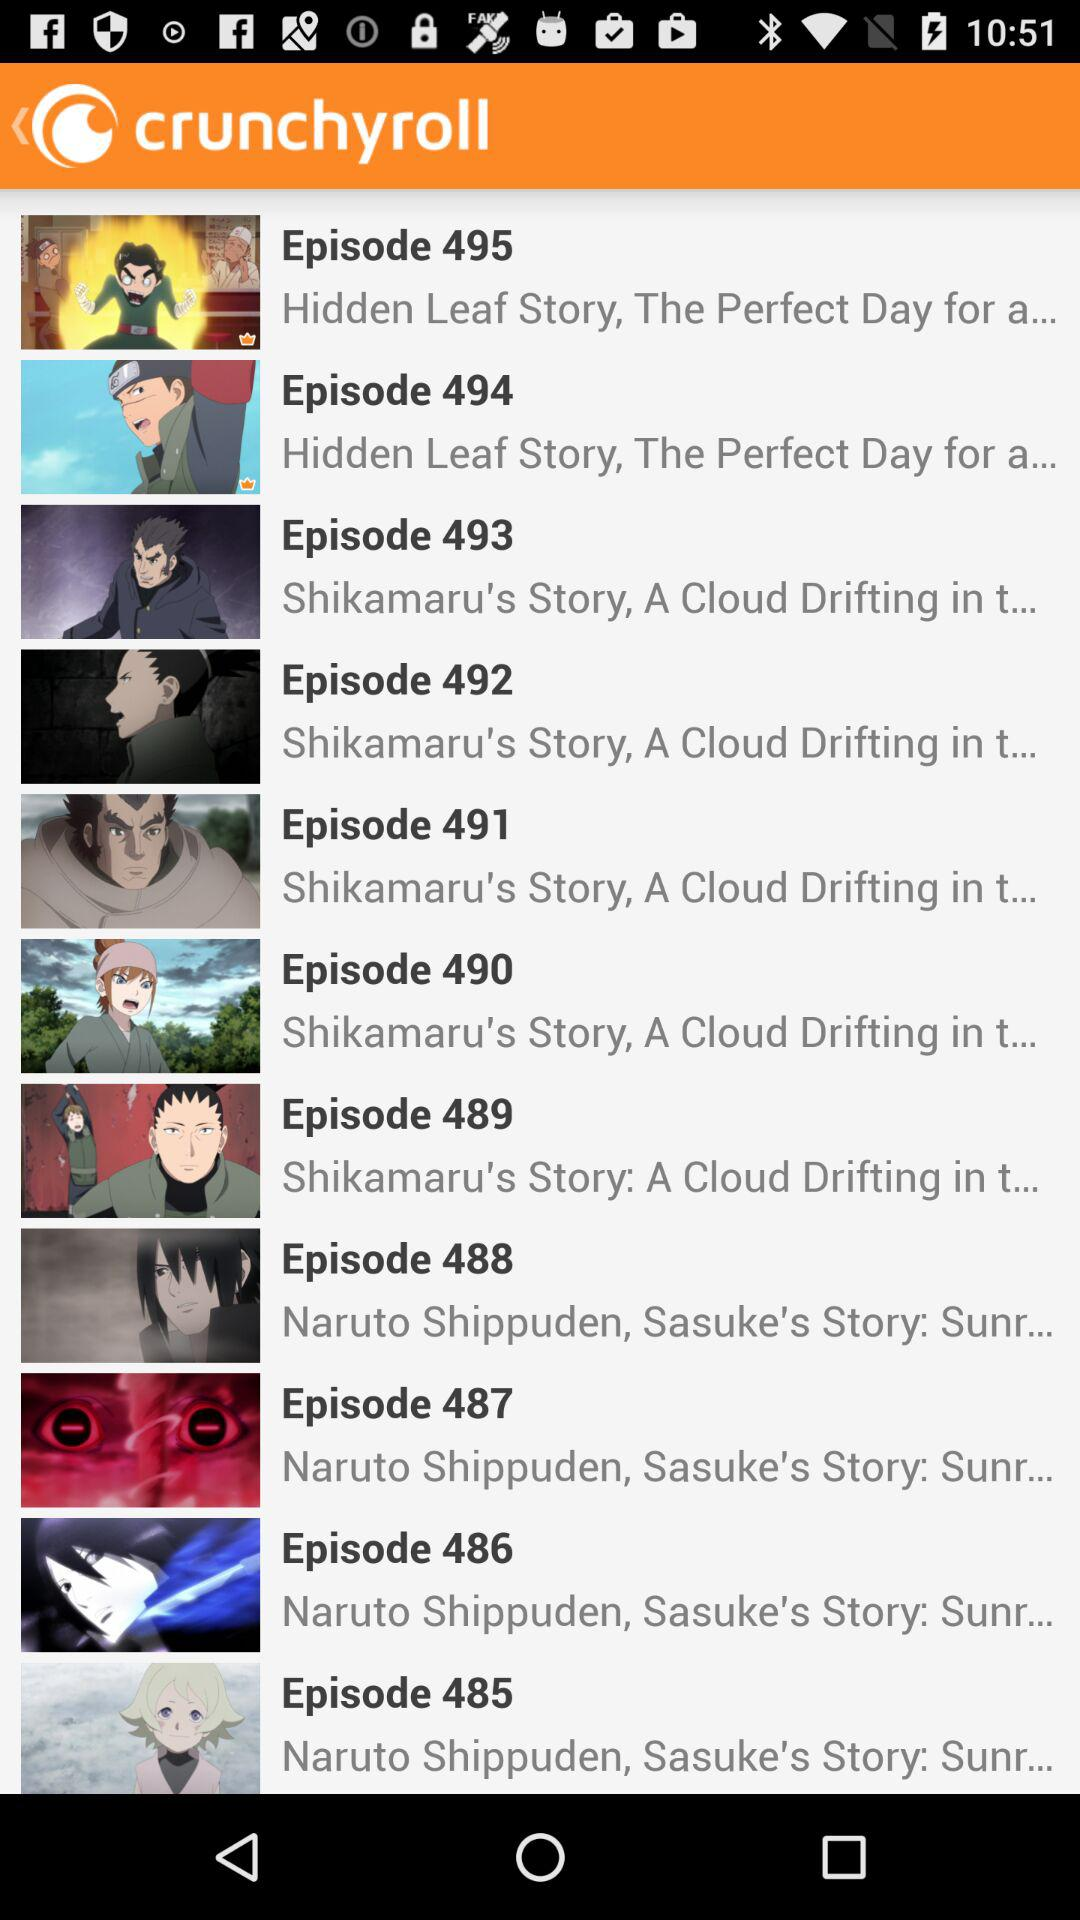What is the title of Episode 486? The title of Episode 486 is "Naruto Shippuden, Sasuke's Story: Sunr...". 